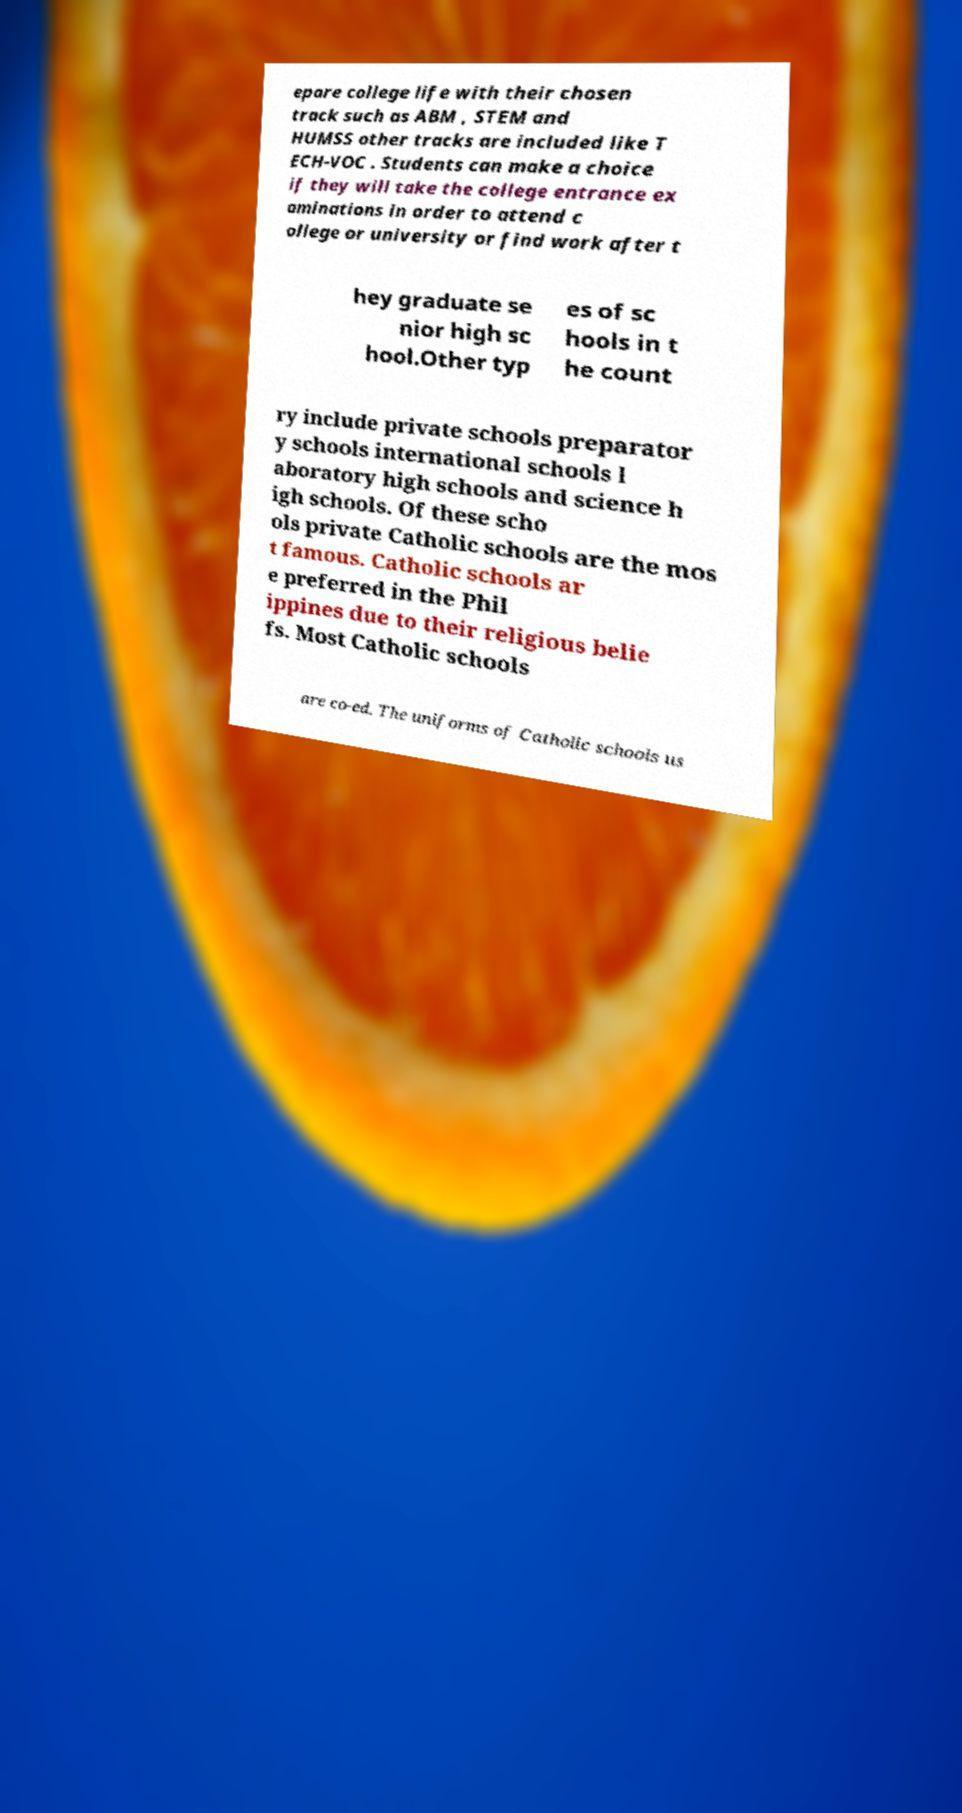Please read and relay the text visible in this image. What does it say? epare college life with their chosen track such as ABM , STEM and HUMSS other tracks are included like T ECH-VOC . Students can make a choice if they will take the college entrance ex aminations in order to attend c ollege or university or find work after t hey graduate se nior high sc hool.Other typ es of sc hools in t he count ry include private schools preparator y schools international schools l aboratory high schools and science h igh schools. Of these scho ols private Catholic schools are the mos t famous. Catholic schools ar e preferred in the Phil ippines due to their religious belie fs. Most Catholic schools are co-ed. The uniforms of Catholic schools us 